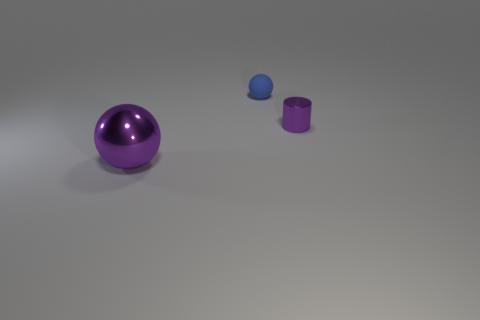Does the size of the objects indicate anything about their distance from each other or the camera? The relative sizes of the objects suggest a decrease in size with increasing distance from the camera, giving a subtle cue to the depth of the scene and the spatial relationship between the objects. Does that affect how we perceive the scene? Yes, the size gradient enhances the perception of depth, making the scene appear three-dimensional and providing a context for the positioning of objects within the space. 